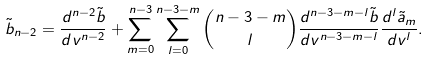Convert formula to latex. <formula><loc_0><loc_0><loc_500><loc_500>\tilde { b } _ { n - 2 } = \frac { d ^ { n - 2 } \tilde { b } } { d v ^ { n - 2 } } + \sum _ { m = 0 } ^ { n - 3 } \sum _ { l = 0 } ^ { n - 3 - m } \binom { n - 3 - m } { l } \frac { d ^ { n - 3 - m - l } \tilde { b } } { d v ^ { n - 3 - m - l } } \frac { d ^ { l } \tilde { a } _ { m } } { d v ^ { l } } .</formula> 